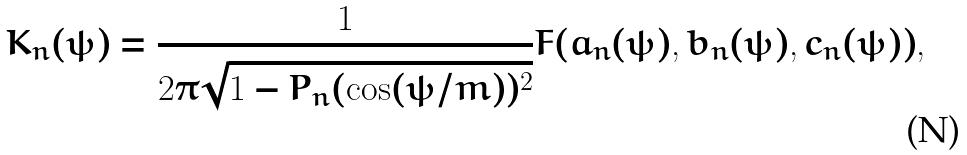Convert formula to latex. <formula><loc_0><loc_0><loc_500><loc_500>K _ { n } ( \psi ) = \frac { 1 } { 2 \pi \sqrt { 1 - P _ { n } ( \cos ( \psi / m ) ) ^ { 2 } } } F ( a _ { n } ( \psi ) , b _ { n } ( \psi ) , c _ { n } ( \psi ) ) ,</formula> 